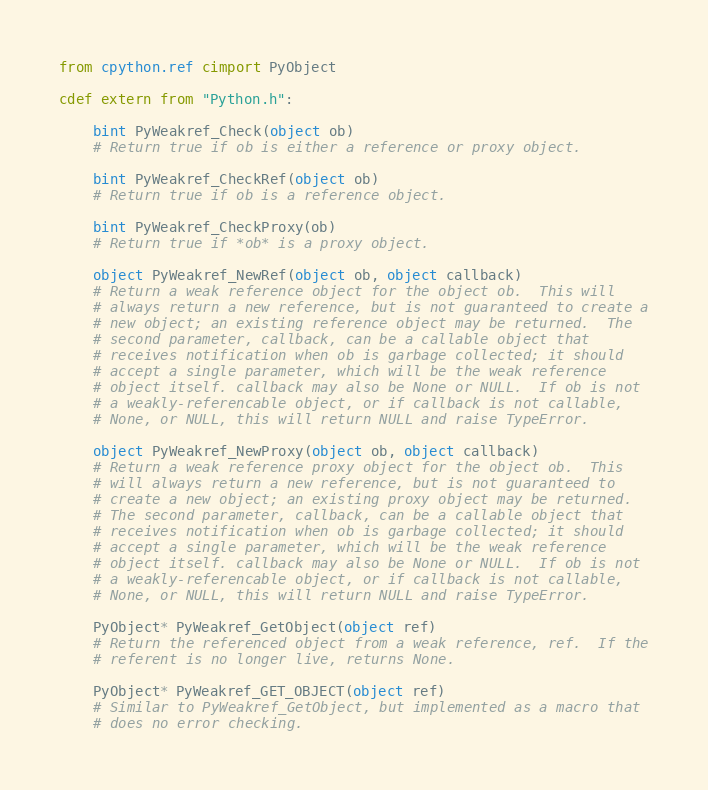<code> <loc_0><loc_0><loc_500><loc_500><_Cython_>from cpython.ref cimport PyObject

cdef extern from "Python.h":

    bint PyWeakref_Check(object ob)
    # Return true if ob is either a reference or proxy object.

    bint PyWeakref_CheckRef(object ob)
    # Return true if ob is a reference object.

    bint PyWeakref_CheckProxy(ob)
    # Return true if *ob* is a proxy object.

    object PyWeakref_NewRef(object ob, object callback)
    # Return a weak reference object for the object ob.  This will
    # always return a new reference, but is not guaranteed to create a
    # new object; an existing reference object may be returned.  The
    # second parameter, callback, can be a callable object that
    # receives notification when ob is garbage collected; it should
    # accept a single parameter, which will be the weak reference
    # object itself. callback may also be None or NULL.  If ob is not
    # a weakly-referencable object, or if callback is not callable,
    # None, or NULL, this will return NULL and raise TypeError.

    object PyWeakref_NewProxy(object ob, object callback)
    # Return a weak reference proxy object for the object ob.  This
    # will always return a new reference, but is not guaranteed to
    # create a new object; an existing proxy object may be returned.
    # The second parameter, callback, can be a callable object that
    # receives notification when ob is garbage collected; it should
    # accept a single parameter, which will be the weak reference
    # object itself. callback may also be None or NULL.  If ob is not
    # a weakly-referencable object, or if callback is not callable,
    # None, or NULL, this will return NULL and raise TypeError.

    PyObject* PyWeakref_GetObject(object ref)
    # Return the referenced object from a weak reference, ref.  If the
    # referent is no longer live, returns None.

    PyObject* PyWeakref_GET_OBJECT(object ref)
    # Similar to PyWeakref_GetObject, but implemented as a macro that
    # does no error checking.
</code> 